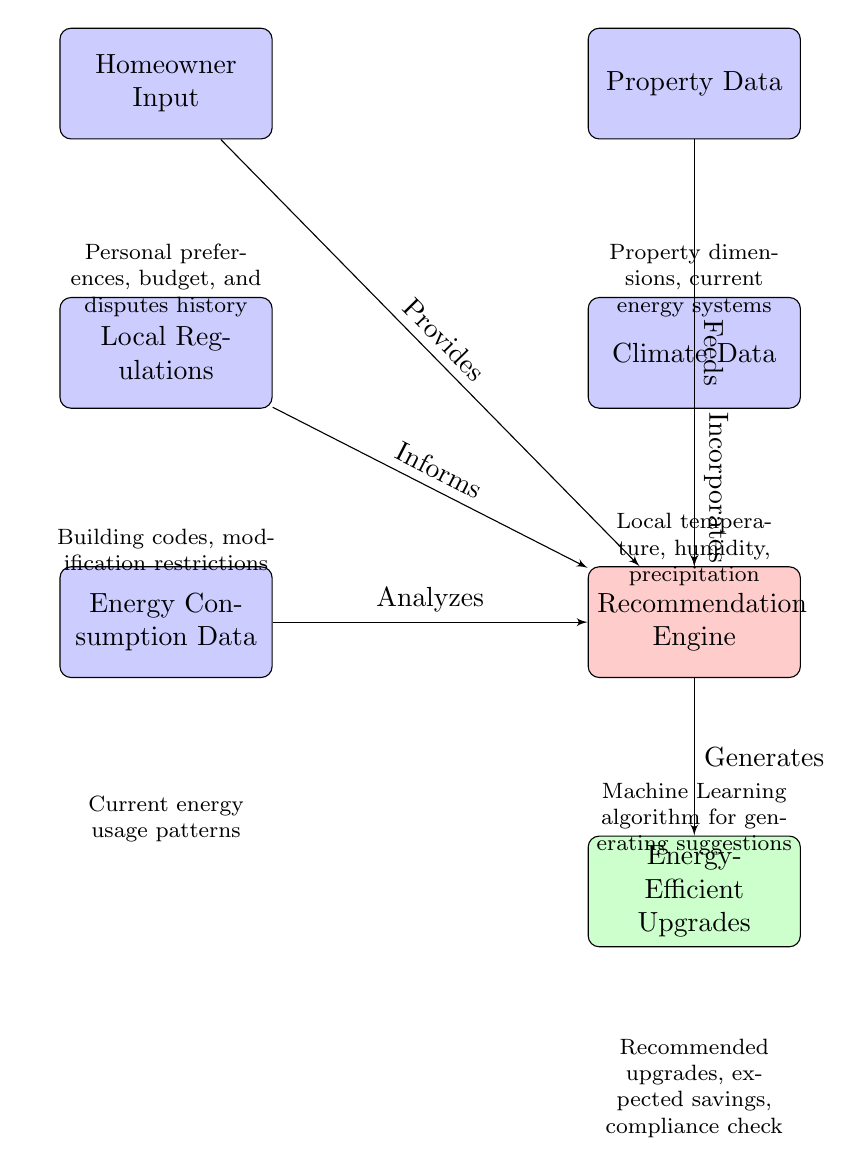What is the first node in the diagram? The first node is labeled "Homeowner Input". It is at the top-left of the diagram and is the starting point for the flow of information.
Answer: Homeowner Input How many nodes are there in total? Counting each distinct block in the diagram, we identify 7 nodes: Homeowner Input, Property Data, Local Regulations, Climate Data, Energy Consumption Data, Recommendation Engine, and Energy-Efficient Upgrades.
Answer: 7 What does the "Local Regulations" node inform? The "Local Regulations" node informs the "Recommendation Engine". This connection indicates that local building codes and modification restrictions play a role in generating recommendations.
Answer: Recommendation Engine Which data does the "Recommendation Engine" generate? The "Recommendation Engine" generates "Energy-Efficient Upgrades". This indicates that the engine's primary function is to produce suggestions for upgrades based on prior inputs.
Answer: Energy-Efficient Upgrades What type of data does "Property Data" provide? "Property Data" provides both dimensions and current energy systems of the property. This information is essential for understanding the specific context for upgrades.
Answer: Property dimensions, current energy systems Which node analyzes energy consumption patterns? The "Energy Consumption Data" node analyzes current energy usage patterns. This analysis is critical for tailoring recommendations to the homeowner's usage behavior.
Answer: Energy Consumption Data What is the purpose of the "Recommendation Engine"? The "Recommendation Engine" uses various types of inputs, including homeowner preferences and local data, to generate actionable suggestions for energy-efficient upgrades.
Answer: Generating suggestions How does "Climate Data" contribute to the system? "Climate Data" contributes by incorporating local temperature, humidity, and precipitation into the "Recommendation Engine", enhancing the relevance of the suggestions based on environmental conditions.
Answer: Incorporates What factors influence the "Homeowner Input"? The "Homeowner Input" is influenced by personal preferences, budget, and disputes history. These aspects help to shape the kind of recommendations the homeowner will receive.
Answer: Personal preferences, budget, and disputes history 